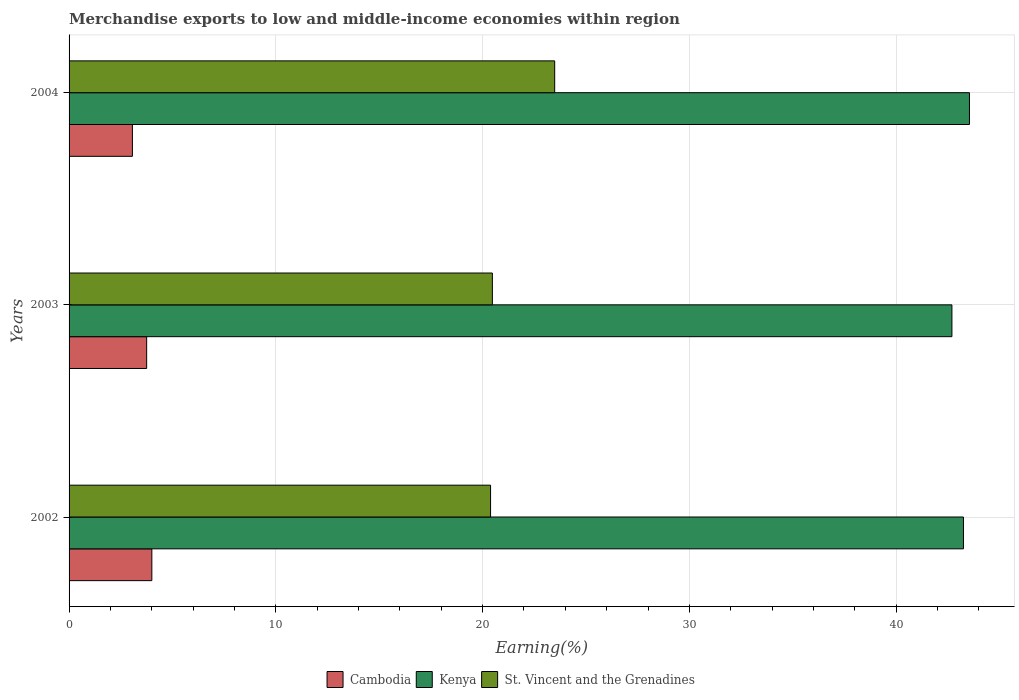Are the number of bars per tick equal to the number of legend labels?
Give a very brief answer. Yes. Are the number of bars on each tick of the Y-axis equal?
Ensure brevity in your answer.  Yes. How many bars are there on the 2nd tick from the top?
Offer a terse response. 3. How many bars are there on the 2nd tick from the bottom?
Keep it short and to the point. 3. In how many cases, is the number of bars for a given year not equal to the number of legend labels?
Give a very brief answer. 0. What is the percentage of amount earned from merchandise exports in Cambodia in 2004?
Give a very brief answer. 3.06. Across all years, what is the maximum percentage of amount earned from merchandise exports in St. Vincent and the Grenadines?
Give a very brief answer. 23.48. Across all years, what is the minimum percentage of amount earned from merchandise exports in Cambodia?
Make the answer very short. 3.06. In which year was the percentage of amount earned from merchandise exports in St. Vincent and the Grenadines maximum?
Your response must be concise. 2004. What is the total percentage of amount earned from merchandise exports in Cambodia in the graph?
Provide a short and direct response. 10.82. What is the difference between the percentage of amount earned from merchandise exports in St. Vincent and the Grenadines in 2003 and that in 2004?
Make the answer very short. -3.01. What is the difference between the percentage of amount earned from merchandise exports in Kenya in 2004 and the percentage of amount earned from merchandise exports in St. Vincent and the Grenadines in 2003?
Your answer should be very brief. 23.07. What is the average percentage of amount earned from merchandise exports in Kenya per year?
Make the answer very short. 43.16. In the year 2003, what is the difference between the percentage of amount earned from merchandise exports in Kenya and percentage of amount earned from merchandise exports in St. Vincent and the Grenadines?
Keep it short and to the point. 22.22. What is the ratio of the percentage of amount earned from merchandise exports in Cambodia in 2002 to that in 2003?
Provide a succinct answer. 1.07. What is the difference between the highest and the second highest percentage of amount earned from merchandise exports in Kenya?
Your answer should be compact. 0.29. What is the difference between the highest and the lowest percentage of amount earned from merchandise exports in St. Vincent and the Grenadines?
Ensure brevity in your answer.  3.1. What does the 2nd bar from the top in 2003 represents?
Your answer should be very brief. Kenya. What does the 1st bar from the bottom in 2004 represents?
Ensure brevity in your answer.  Cambodia. Is it the case that in every year, the sum of the percentage of amount earned from merchandise exports in St. Vincent and the Grenadines and percentage of amount earned from merchandise exports in Kenya is greater than the percentage of amount earned from merchandise exports in Cambodia?
Your answer should be compact. Yes. Are all the bars in the graph horizontal?
Your answer should be very brief. Yes. How many years are there in the graph?
Offer a terse response. 3. What is the difference between two consecutive major ticks on the X-axis?
Your response must be concise. 10. Are the values on the major ticks of X-axis written in scientific E-notation?
Your answer should be very brief. No. Does the graph contain any zero values?
Give a very brief answer. No. Does the graph contain grids?
Your answer should be very brief. Yes. Where does the legend appear in the graph?
Ensure brevity in your answer.  Bottom center. How are the legend labels stacked?
Your response must be concise. Horizontal. What is the title of the graph?
Keep it short and to the point. Merchandise exports to low and middle-income economies within region. What is the label or title of the X-axis?
Provide a succinct answer. Earning(%). What is the Earning(%) in Cambodia in 2002?
Your answer should be very brief. 4. What is the Earning(%) in Kenya in 2002?
Ensure brevity in your answer.  43.25. What is the Earning(%) in St. Vincent and the Grenadines in 2002?
Your answer should be compact. 20.38. What is the Earning(%) of Cambodia in 2003?
Your response must be concise. 3.75. What is the Earning(%) of Kenya in 2003?
Offer a very short reply. 42.69. What is the Earning(%) in St. Vincent and the Grenadines in 2003?
Your answer should be very brief. 20.47. What is the Earning(%) of Cambodia in 2004?
Your answer should be compact. 3.06. What is the Earning(%) in Kenya in 2004?
Offer a terse response. 43.54. What is the Earning(%) in St. Vincent and the Grenadines in 2004?
Provide a short and direct response. 23.48. Across all years, what is the maximum Earning(%) in Cambodia?
Ensure brevity in your answer.  4. Across all years, what is the maximum Earning(%) in Kenya?
Keep it short and to the point. 43.54. Across all years, what is the maximum Earning(%) of St. Vincent and the Grenadines?
Give a very brief answer. 23.48. Across all years, what is the minimum Earning(%) in Cambodia?
Your answer should be very brief. 3.06. Across all years, what is the minimum Earning(%) of Kenya?
Give a very brief answer. 42.69. Across all years, what is the minimum Earning(%) in St. Vincent and the Grenadines?
Your answer should be very brief. 20.38. What is the total Earning(%) in Cambodia in the graph?
Give a very brief answer. 10.82. What is the total Earning(%) of Kenya in the graph?
Ensure brevity in your answer.  129.49. What is the total Earning(%) in St. Vincent and the Grenadines in the graph?
Offer a terse response. 64.34. What is the difference between the Earning(%) in Cambodia in 2002 and that in 2003?
Offer a very short reply. 0.25. What is the difference between the Earning(%) of Kenya in 2002 and that in 2003?
Offer a terse response. 0.56. What is the difference between the Earning(%) in St. Vincent and the Grenadines in 2002 and that in 2003?
Your answer should be compact. -0.09. What is the difference between the Earning(%) in Cambodia in 2002 and that in 2004?
Keep it short and to the point. 0.94. What is the difference between the Earning(%) in Kenya in 2002 and that in 2004?
Offer a very short reply. -0.29. What is the difference between the Earning(%) of St. Vincent and the Grenadines in 2002 and that in 2004?
Offer a very short reply. -3.1. What is the difference between the Earning(%) of Cambodia in 2003 and that in 2004?
Provide a short and direct response. 0.69. What is the difference between the Earning(%) of Kenya in 2003 and that in 2004?
Give a very brief answer. -0.85. What is the difference between the Earning(%) of St. Vincent and the Grenadines in 2003 and that in 2004?
Offer a very short reply. -3.01. What is the difference between the Earning(%) of Cambodia in 2002 and the Earning(%) of Kenya in 2003?
Ensure brevity in your answer.  -38.69. What is the difference between the Earning(%) in Cambodia in 2002 and the Earning(%) in St. Vincent and the Grenadines in 2003?
Keep it short and to the point. -16.47. What is the difference between the Earning(%) in Kenya in 2002 and the Earning(%) in St. Vincent and the Grenadines in 2003?
Your answer should be compact. 22.78. What is the difference between the Earning(%) of Cambodia in 2002 and the Earning(%) of Kenya in 2004?
Give a very brief answer. -39.54. What is the difference between the Earning(%) of Cambodia in 2002 and the Earning(%) of St. Vincent and the Grenadines in 2004?
Give a very brief answer. -19.48. What is the difference between the Earning(%) in Kenya in 2002 and the Earning(%) in St. Vincent and the Grenadines in 2004?
Ensure brevity in your answer.  19.77. What is the difference between the Earning(%) in Cambodia in 2003 and the Earning(%) in Kenya in 2004?
Your response must be concise. -39.79. What is the difference between the Earning(%) in Cambodia in 2003 and the Earning(%) in St. Vincent and the Grenadines in 2004?
Keep it short and to the point. -19.73. What is the difference between the Earning(%) of Kenya in 2003 and the Earning(%) of St. Vincent and the Grenadines in 2004?
Make the answer very short. 19.21. What is the average Earning(%) in Cambodia per year?
Make the answer very short. 3.61. What is the average Earning(%) in Kenya per year?
Provide a succinct answer. 43.16. What is the average Earning(%) of St. Vincent and the Grenadines per year?
Provide a short and direct response. 21.45. In the year 2002, what is the difference between the Earning(%) in Cambodia and Earning(%) in Kenya?
Ensure brevity in your answer.  -39.25. In the year 2002, what is the difference between the Earning(%) of Cambodia and Earning(%) of St. Vincent and the Grenadines?
Offer a terse response. -16.38. In the year 2002, what is the difference between the Earning(%) of Kenya and Earning(%) of St. Vincent and the Grenadines?
Keep it short and to the point. 22.87. In the year 2003, what is the difference between the Earning(%) in Cambodia and Earning(%) in Kenya?
Your response must be concise. -38.94. In the year 2003, what is the difference between the Earning(%) of Cambodia and Earning(%) of St. Vincent and the Grenadines?
Give a very brief answer. -16.72. In the year 2003, what is the difference between the Earning(%) in Kenya and Earning(%) in St. Vincent and the Grenadines?
Offer a terse response. 22.22. In the year 2004, what is the difference between the Earning(%) of Cambodia and Earning(%) of Kenya?
Your answer should be very brief. -40.48. In the year 2004, what is the difference between the Earning(%) of Cambodia and Earning(%) of St. Vincent and the Grenadines?
Your response must be concise. -20.42. In the year 2004, what is the difference between the Earning(%) of Kenya and Earning(%) of St. Vincent and the Grenadines?
Give a very brief answer. 20.06. What is the ratio of the Earning(%) of Cambodia in 2002 to that in 2003?
Ensure brevity in your answer.  1.07. What is the ratio of the Earning(%) in Kenya in 2002 to that in 2003?
Offer a terse response. 1.01. What is the ratio of the Earning(%) of Cambodia in 2002 to that in 2004?
Your answer should be compact. 1.31. What is the ratio of the Earning(%) in St. Vincent and the Grenadines in 2002 to that in 2004?
Ensure brevity in your answer.  0.87. What is the ratio of the Earning(%) of Cambodia in 2003 to that in 2004?
Give a very brief answer. 1.22. What is the ratio of the Earning(%) of Kenya in 2003 to that in 2004?
Your answer should be compact. 0.98. What is the ratio of the Earning(%) of St. Vincent and the Grenadines in 2003 to that in 2004?
Offer a very short reply. 0.87. What is the difference between the highest and the second highest Earning(%) in Cambodia?
Offer a very short reply. 0.25. What is the difference between the highest and the second highest Earning(%) in Kenya?
Offer a terse response. 0.29. What is the difference between the highest and the second highest Earning(%) in St. Vincent and the Grenadines?
Your answer should be compact. 3.01. What is the difference between the highest and the lowest Earning(%) of Cambodia?
Provide a succinct answer. 0.94. What is the difference between the highest and the lowest Earning(%) of Kenya?
Make the answer very short. 0.85. What is the difference between the highest and the lowest Earning(%) of St. Vincent and the Grenadines?
Keep it short and to the point. 3.1. 